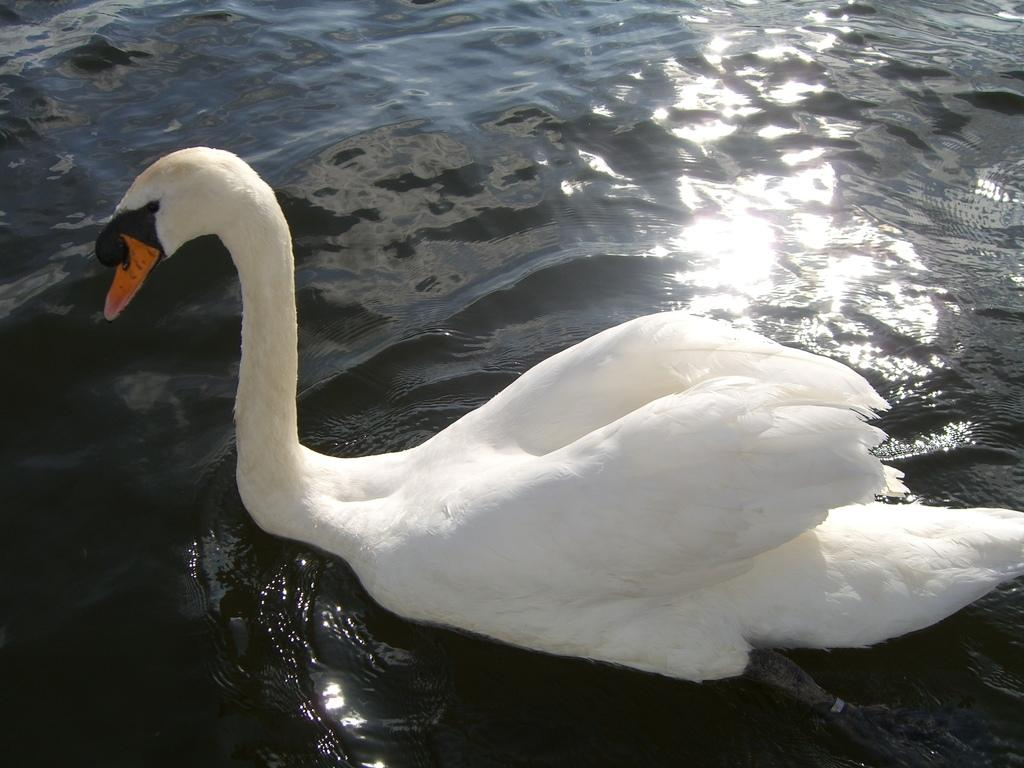What animal is present in the image? There is a swan in the image. Where is the swan located? The swan is on the water. What type of stone can be seen on the roof of the swan in the image? There is no stone or roof present on the swan in the image, as it is a bird and not a structure. 